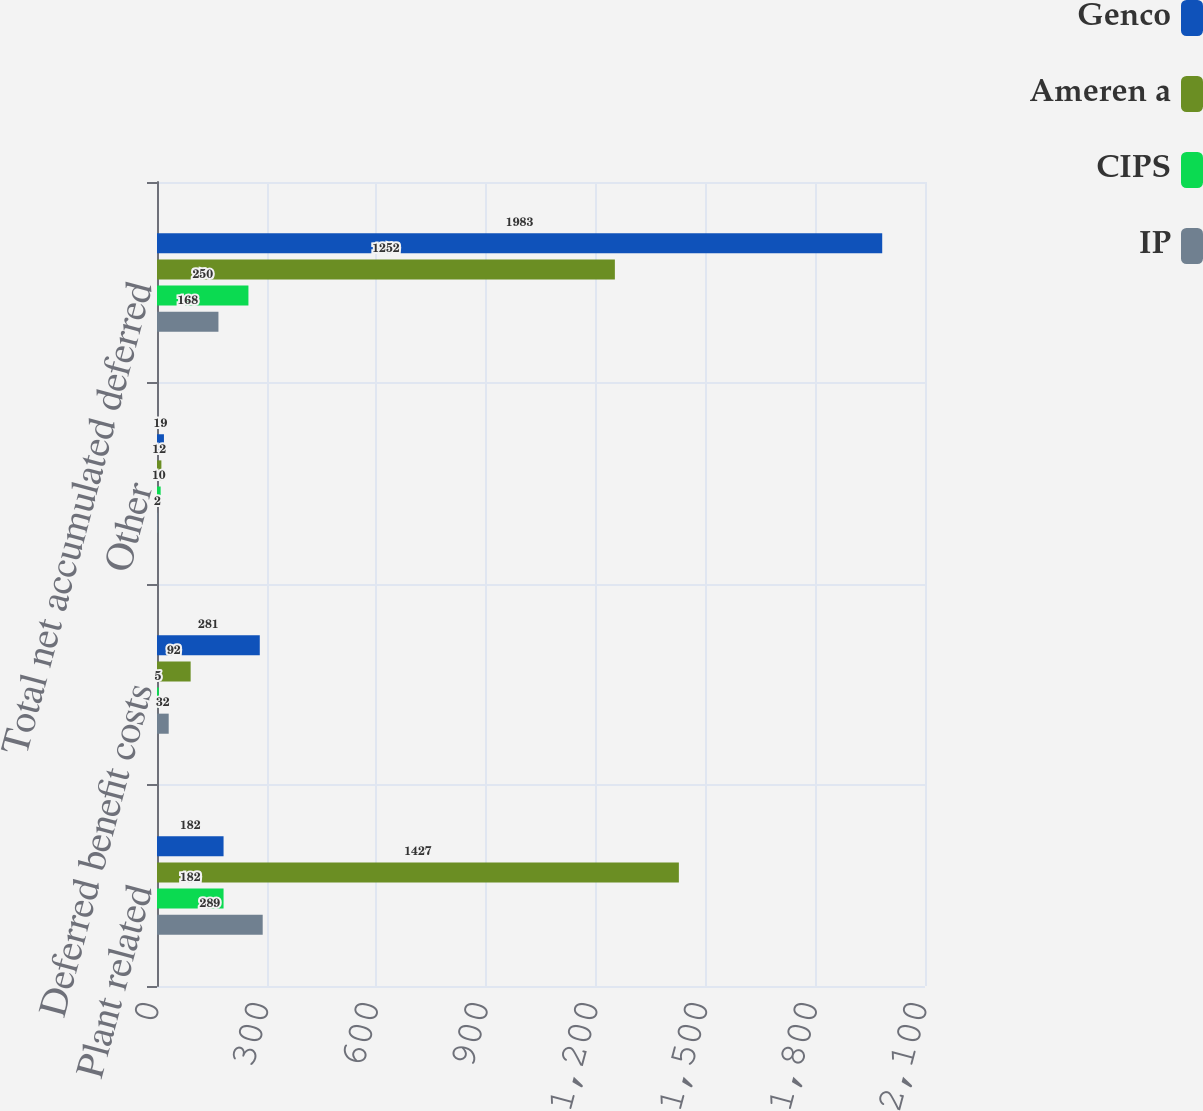Convert chart. <chart><loc_0><loc_0><loc_500><loc_500><stacked_bar_chart><ecel><fcel>Plant related<fcel>Deferred benefit costs<fcel>Other<fcel>Total net accumulated deferred<nl><fcel>Genco<fcel>182<fcel>281<fcel>19<fcel>1983<nl><fcel>Ameren a<fcel>1427<fcel>92<fcel>12<fcel>1252<nl><fcel>CIPS<fcel>182<fcel>5<fcel>10<fcel>250<nl><fcel>IP<fcel>289<fcel>32<fcel>2<fcel>168<nl></chart> 